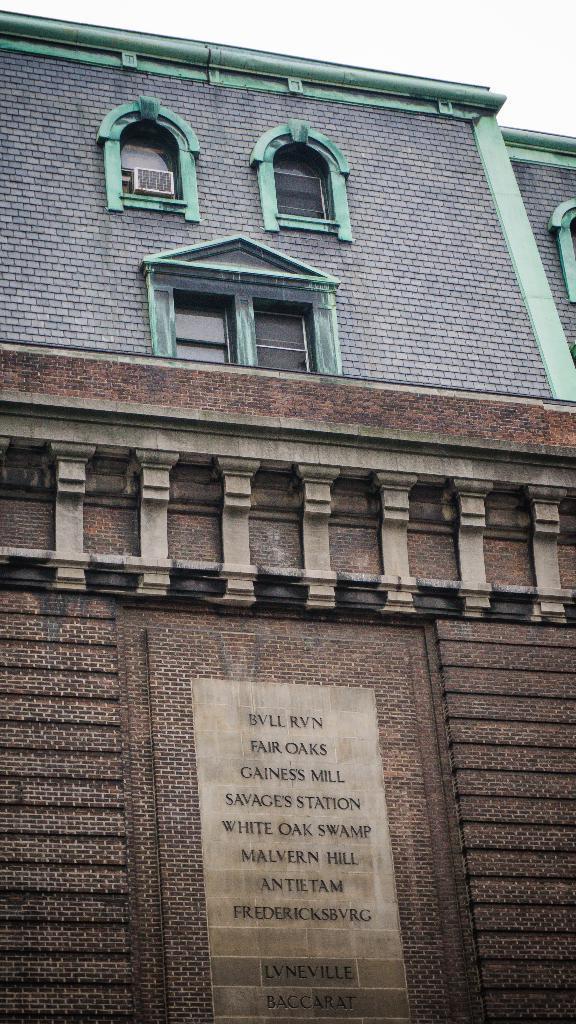Describe this image in one or two sentences. In the image there is a building with walls, windows, air conditioner and on the wall there are many names. And also there are designs on the wall. 